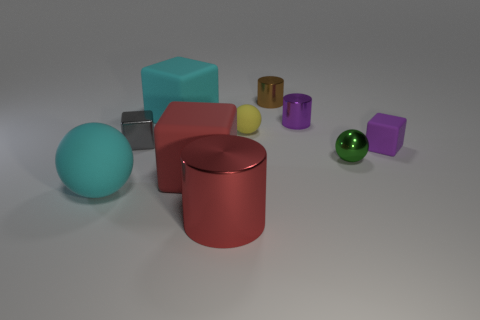Subtract all blocks. How many objects are left? 6 Add 9 cyan matte balls. How many cyan matte balls exist? 10 Subtract 0 yellow cubes. How many objects are left? 10 Subtract all cyan matte blocks. Subtract all big things. How many objects are left? 5 Add 8 big red things. How many big red things are left? 10 